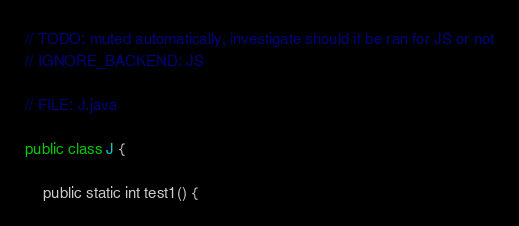Convert code to text. <code><loc_0><loc_0><loc_500><loc_500><_Kotlin_>// TODO: muted automatically, investigate should it be ran for JS or not
// IGNORE_BACKEND: JS

// FILE: J.java

public class J {

    public static int test1() {</code> 